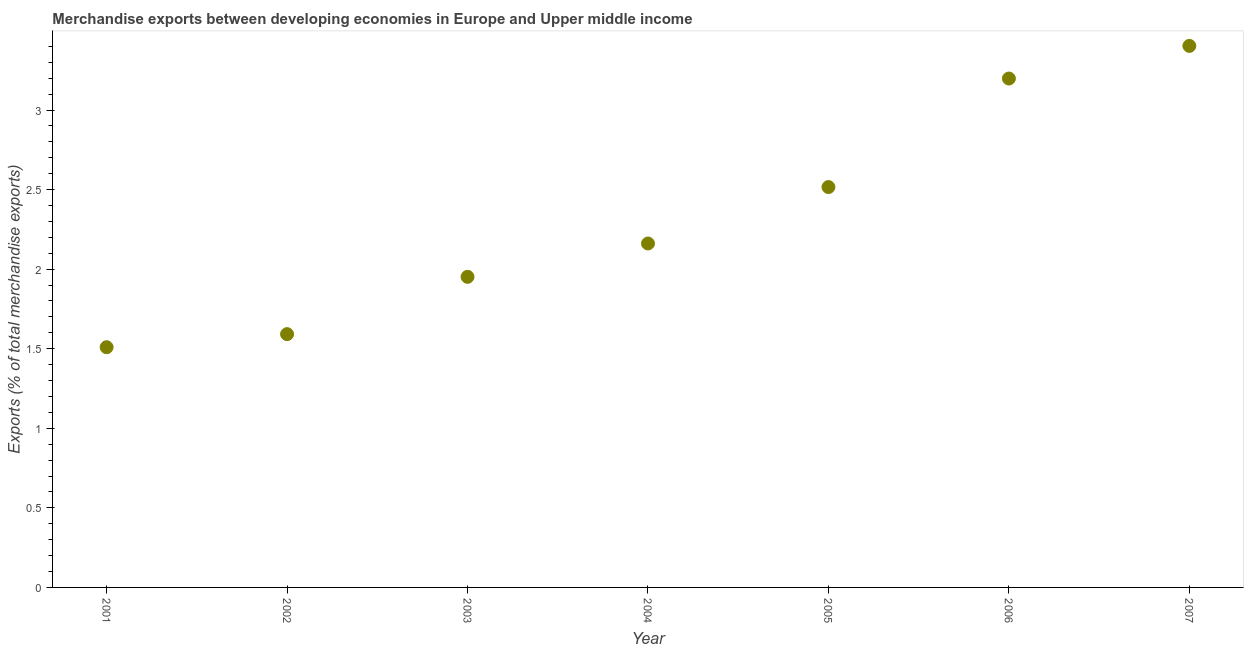What is the merchandise exports in 2001?
Provide a short and direct response. 1.51. Across all years, what is the maximum merchandise exports?
Ensure brevity in your answer.  3.4. Across all years, what is the minimum merchandise exports?
Offer a very short reply. 1.51. What is the sum of the merchandise exports?
Provide a succinct answer. 16.33. What is the difference between the merchandise exports in 2002 and 2003?
Provide a succinct answer. -0.36. What is the average merchandise exports per year?
Make the answer very short. 2.33. What is the median merchandise exports?
Offer a very short reply. 2.16. What is the ratio of the merchandise exports in 2002 to that in 2004?
Your response must be concise. 0.74. Is the merchandise exports in 2001 less than that in 2002?
Provide a short and direct response. Yes. Is the difference between the merchandise exports in 2002 and 2007 greater than the difference between any two years?
Offer a very short reply. No. What is the difference between the highest and the second highest merchandise exports?
Your response must be concise. 0.21. Is the sum of the merchandise exports in 2002 and 2003 greater than the maximum merchandise exports across all years?
Offer a very short reply. Yes. What is the difference between the highest and the lowest merchandise exports?
Your response must be concise. 1.89. In how many years, is the merchandise exports greater than the average merchandise exports taken over all years?
Keep it short and to the point. 3. Does the merchandise exports monotonically increase over the years?
Provide a succinct answer. Yes. How many years are there in the graph?
Provide a short and direct response. 7. What is the difference between two consecutive major ticks on the Y-axis?
Offer a terse response. 0.5. Does the graph contain any zero values?
Your answer should be compact. No. What is the title of the graph?
Offer a terse response. Merchandise exports between developing economies in Europe and Upper middle income. What is the label or title of the Y-axis?
Your answer should be compact. Exports (% of total merchandise exports). What is the Exports (% of total merchandise exports) in 2001?
Your answer should be very brief. 1.51. What is the Exports (% of total merchandise exports) in 2002?
Ensure brevity in your answer.  1.59. What is the Exports (% of total merchandise exports) in 2003?
Give a very brief answer. 1.95. What is the Exports (% of total merchandise exports) in 2004?
Make the answer very short. 2.16. What is the Exports (% of total merchandise exports) in 2005?
Provide a succinct answer. 2.52. What is the Exports (% of total merchandise exports) in 2006?
Provide a short and direct response. 3.2. What is the Exports (% of total merchandise exports) in 2007?
Your answer should be very brief. 3.4. What is the difference between the Exports (% of total merchandise exports) in 2001 and 2002?
Provide a short and direct response. -0.08. What is the difference between the Exports (% of total merchandise exports) in 2001 and 2003?
Provide a succinct answer. -0.44. What is the difference between the Exports (% of total merchandise exports) in 2001 and 2004?
Offer a very short reply. -0.65. What is the difference between the Exports (% of total merchandise exports) in 2001 and 2005?
Provide a succinct answer. -1.01. What is the difference between the Exports (% of total merchandise exports) in 2001 and 2006?
Offer a terse response. -1.69. What is the difference between the Exports (% of total merchandise exports) in 2001 and 2007?
Your answer should be compact. -1.89. What is the difference between the Exports (% of total merchandise exports) in 2002 and 2003?
Provide a succinct answer. -0.36. What is the difference between the Exports (% of total merchandise exports) in 2002 and 2004?
Make the answer very short. -0.57. What is the difference between the Exports (% of total merchandise exports) in 2002 and 2005?
Keep it short and to the point. -0.92. What is the difference between the Exports (% of total merchandise exports) in 2002 and 2006?
Keep it short and to the point. -1.61. What is the difference between the Exports (% of total merchandise exports) in 2002 and 2007?
Your answer should be compact. -1.81. What is the difference between the Exports (% of total merchandise exports) in 2003 and 2004?
Your answer should be compact. -0.21. What is the difference between the Exports (% of total merchandise exports) in 2003 and 2005?
Make the answer very short. -0.56. What is the difference between the Exports (% of total merchandise exports) in 2003 and 2006?
Your answer should be very brief. -1.25. What is the difference between the Exports (% of total merchandise exports) in 2003 and 2007?
Your answer should be very brief. -1.45. What is the difference between the Exports (% of total merchandise exports) in 2004 and 2005?
Provide a short and direct response. -0.35. What is the difference between the Exports (% of total merchandise exports) in 2004 and 2006?
Keep it short and to the point. -1.04. What is the difference between the Exports (% of total merchandise exports) in 2004 and 2007?
Make the answer very short. -1.24. What is the difference between the Exports (% of total merchandise exports) in 2005 and 2006?
Your answer should be compact. -0.68. What is the difference between the Exports (% of total merchandise exports) in 2005 and 2007?
Your answer should be compact. -0.89. What is the difference between the Exports (% of total merchandise exports) in 2006 and 2007?
Offer a very short reply. -0.21. What is the ratio of the Exports (% of total merchandise exports) in 2001 to that in 2002?
Give a very brief answer. 0.95. What is the ratio of the Exports (% of total merchandise exports) in 2001 to that in 2003?
Your response must be concise. 0.77. What is the ratio of the Exports (% of total merchandise exports) in 2001 to that in 2004?
Provide a succinct answer. 0.7. What is the ratio of the Exports (% of total merchandise exports) in 2001 to that in 2006?
Ensure brevity in your answer.  0.47. What is the ratio of the Exports (% of total merchandise exports) in 2001 to that in 2007?
Your response must be concise. 0.44. What is the ratio of the Exports (% of total merchandise exports) in 2002 to that in 2003?
Your answer should be very brief. 0.82. What is the ratio of the Exports (% of total merchandise exports) in 2002 to that in 2004?
Provide a succinct answer. 0.74. What is the ratio of the Exports (% of total merchandise exports) in 2002 to that in 2005?
Ensure brevity in your answer.  0.63. What is the ratio of the Exports (% of total merchandise exports) in 2002 to that in 2006?
Offer a terse response. 0.5. What is the ratio of the Exports (% of total merchandise exports) in 2002 to that in 2007?
Make the answer very short. 0.47. What is the ratio of the Exports (% of total merchandise exports) in 2003 to that in 2004?
Keep it short and to the point. 0.9. What is the ratio of the Exports (% of total merchandise exports) in 2003 to that in 2005?
Your response must be concise. 0.78. What is the ratio of the Exports (% of total merchandise exports) in 2003 to that in 2006?
Keep it short and to the point. 0.61. What is the ratio of the Exports (% of total merchandise exports) in 2003 to that in 2007?
Ensure brevity in your answer.  0.57. What is the ratio of the Exports (% of total merchandise exports) in 2004 to that in 2005?
Make the answer very short. 0.86. What is the ratio of the Exports (% of total merchandise exports) in 2004 to that in 2006?
Offer a terse response. 0.68. What is the ratio of the Exports (% of total merchandise exports) in 2004 to that in 2007?
Offer a very short reply. 0.64. What is the ratio of the Exports (% of total merchandise exports) in 2005 to that in 2006?
Offer a very short reply. 0.79. What is the ratio of the Exports (% of total merchandise exports) in 2005 to that in 2007?
Give a very brief answer. 0.74. What is the ratio of the Exports (% of total merchandise exports) in 2006 to that in 2007?
Offer a terse response. 0.94. 